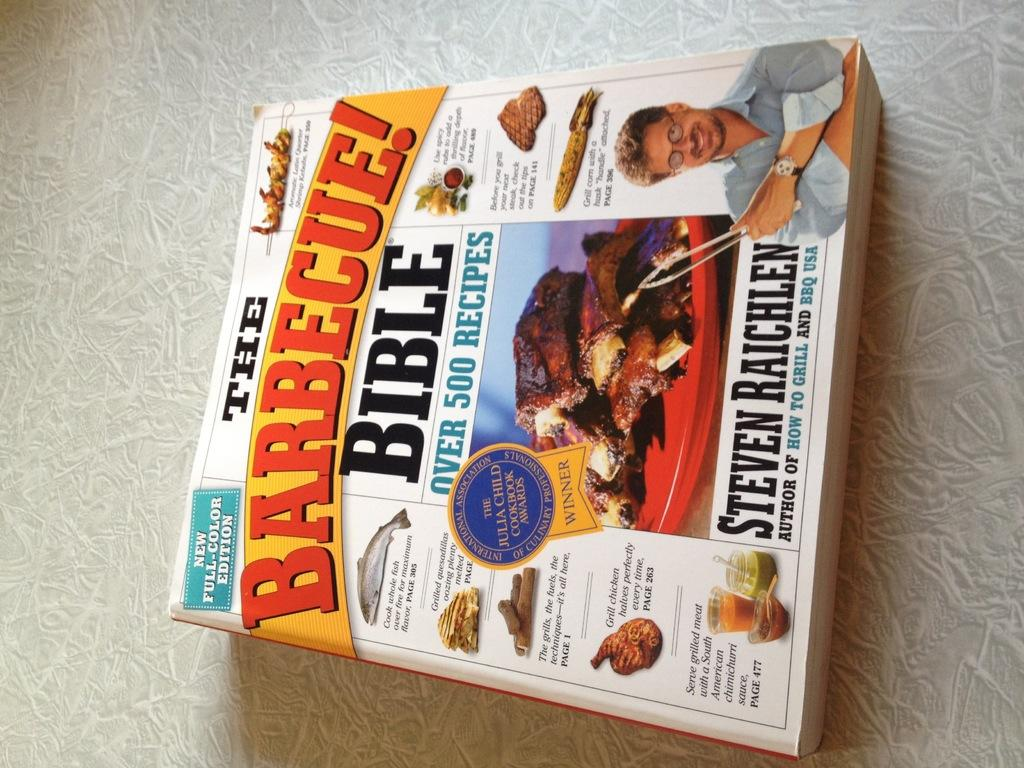Provide a one-sentence caption for the provided image. Serious cookout fans should avail themselves of the Barbecue! Bible. 